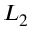<formula> <loc_0><loc_0><loc_500><loc_500>L _ { 2 }</formula> 